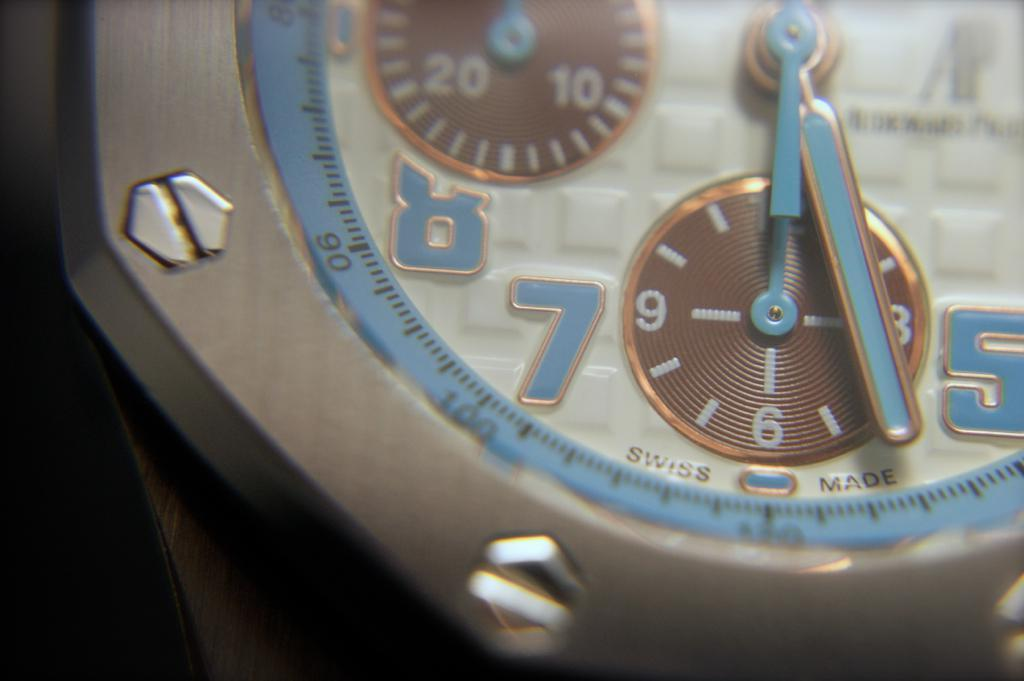<image>
Summarize the visual content of the image. Face of a watch which says SWISS MADE on it. 